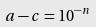Convert formula to latex. <formula><loc_0><loc_0><loc_500><loc_500>a - c = 1 0 ^ { - n }</formula> 